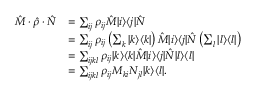<formula> <loc_0><loc_0><loc_500><loc_500>\begin{array} { r l } { \quad \hat { M } \cdot \hat { \rho } \cdot \hat { N } } & { = \sum _ { i j } \rho _ { i j } \hat { M } | i \rangle \langle j | \hat { N } } \\ & { = \sum _ { i j } \rho _ { i j } \left ( \sum _ { k } | k \rangle \langle k | \right ) \hat { M } | i \rangle \langle j | \hat { N } \left ( \sum _ { l } | l \rangle \langle l | \right ) } \\ & { = \sum _ { i j k l } \rho _ { i j } | k \rangle \langle k | \hat { M } | i \rangle \langle j | \hat { N } | l \rangle \langle l | } \\ & { = \sum _ { i j k l } \rho _ { i j } M _ { k i } N _ { j l } | k \rangle \langle l | . } \end{array}</formula> 